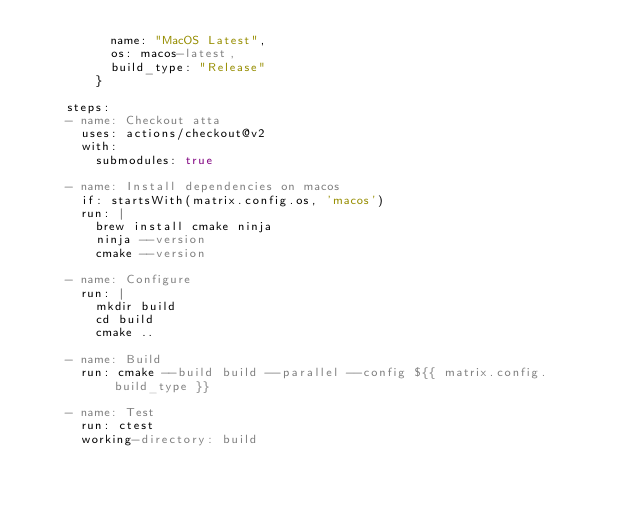Convert code to text. <code><loc_0><loc_0><loc_500><loc_500><_YAML_>          name: "MacOS Latest",
          os: macos-latest,
          build_type: "Release"
        }

    steps:
    - name: Checkout atta
      uses: actions/checkout@v2
      with:
        submodules: true

    - name: Install dependencies on macos
      if: startsWith(matrix.config.os, 'macos')
      run: |
        brew install cmake ninja
        ninja --version
        cmake --version

    - name: Configure
      run: |
        mkdir build
        cd build
        cmake ..

    - name: Build
      run: cmake --build build --parallel --config ${{ matrix.config.build_type }}

    - name: Test
      run: ctest
      working-directory: build
</code> 